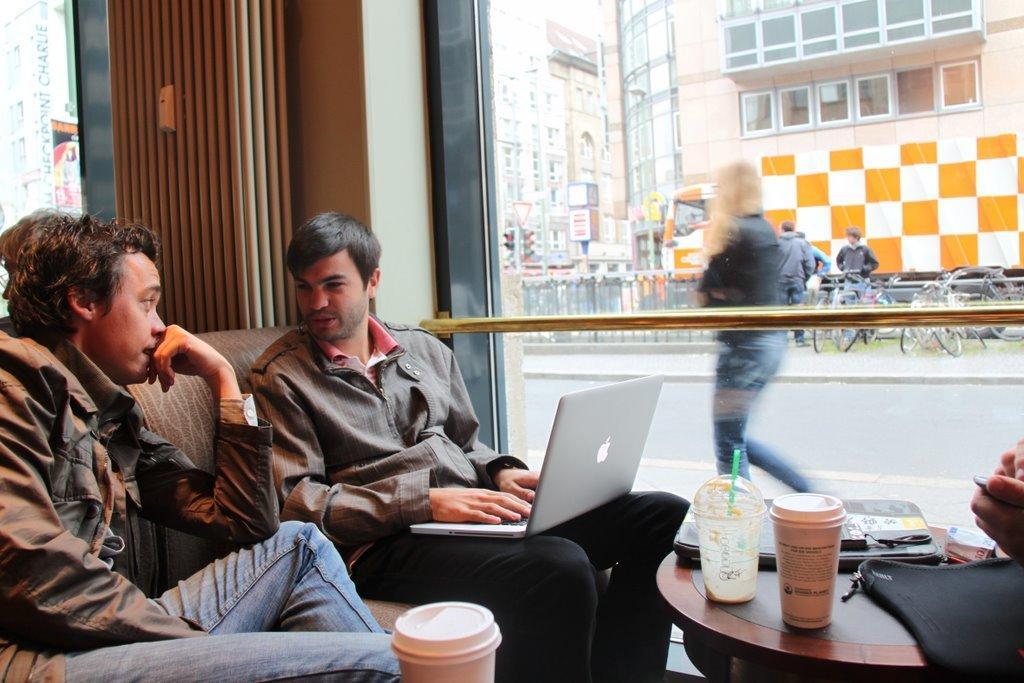Please provide a concise description of this image. In the given image we can see two men sitting on sofa and talking to each other. There is table on which a glass is kept. There is a window beside them. 